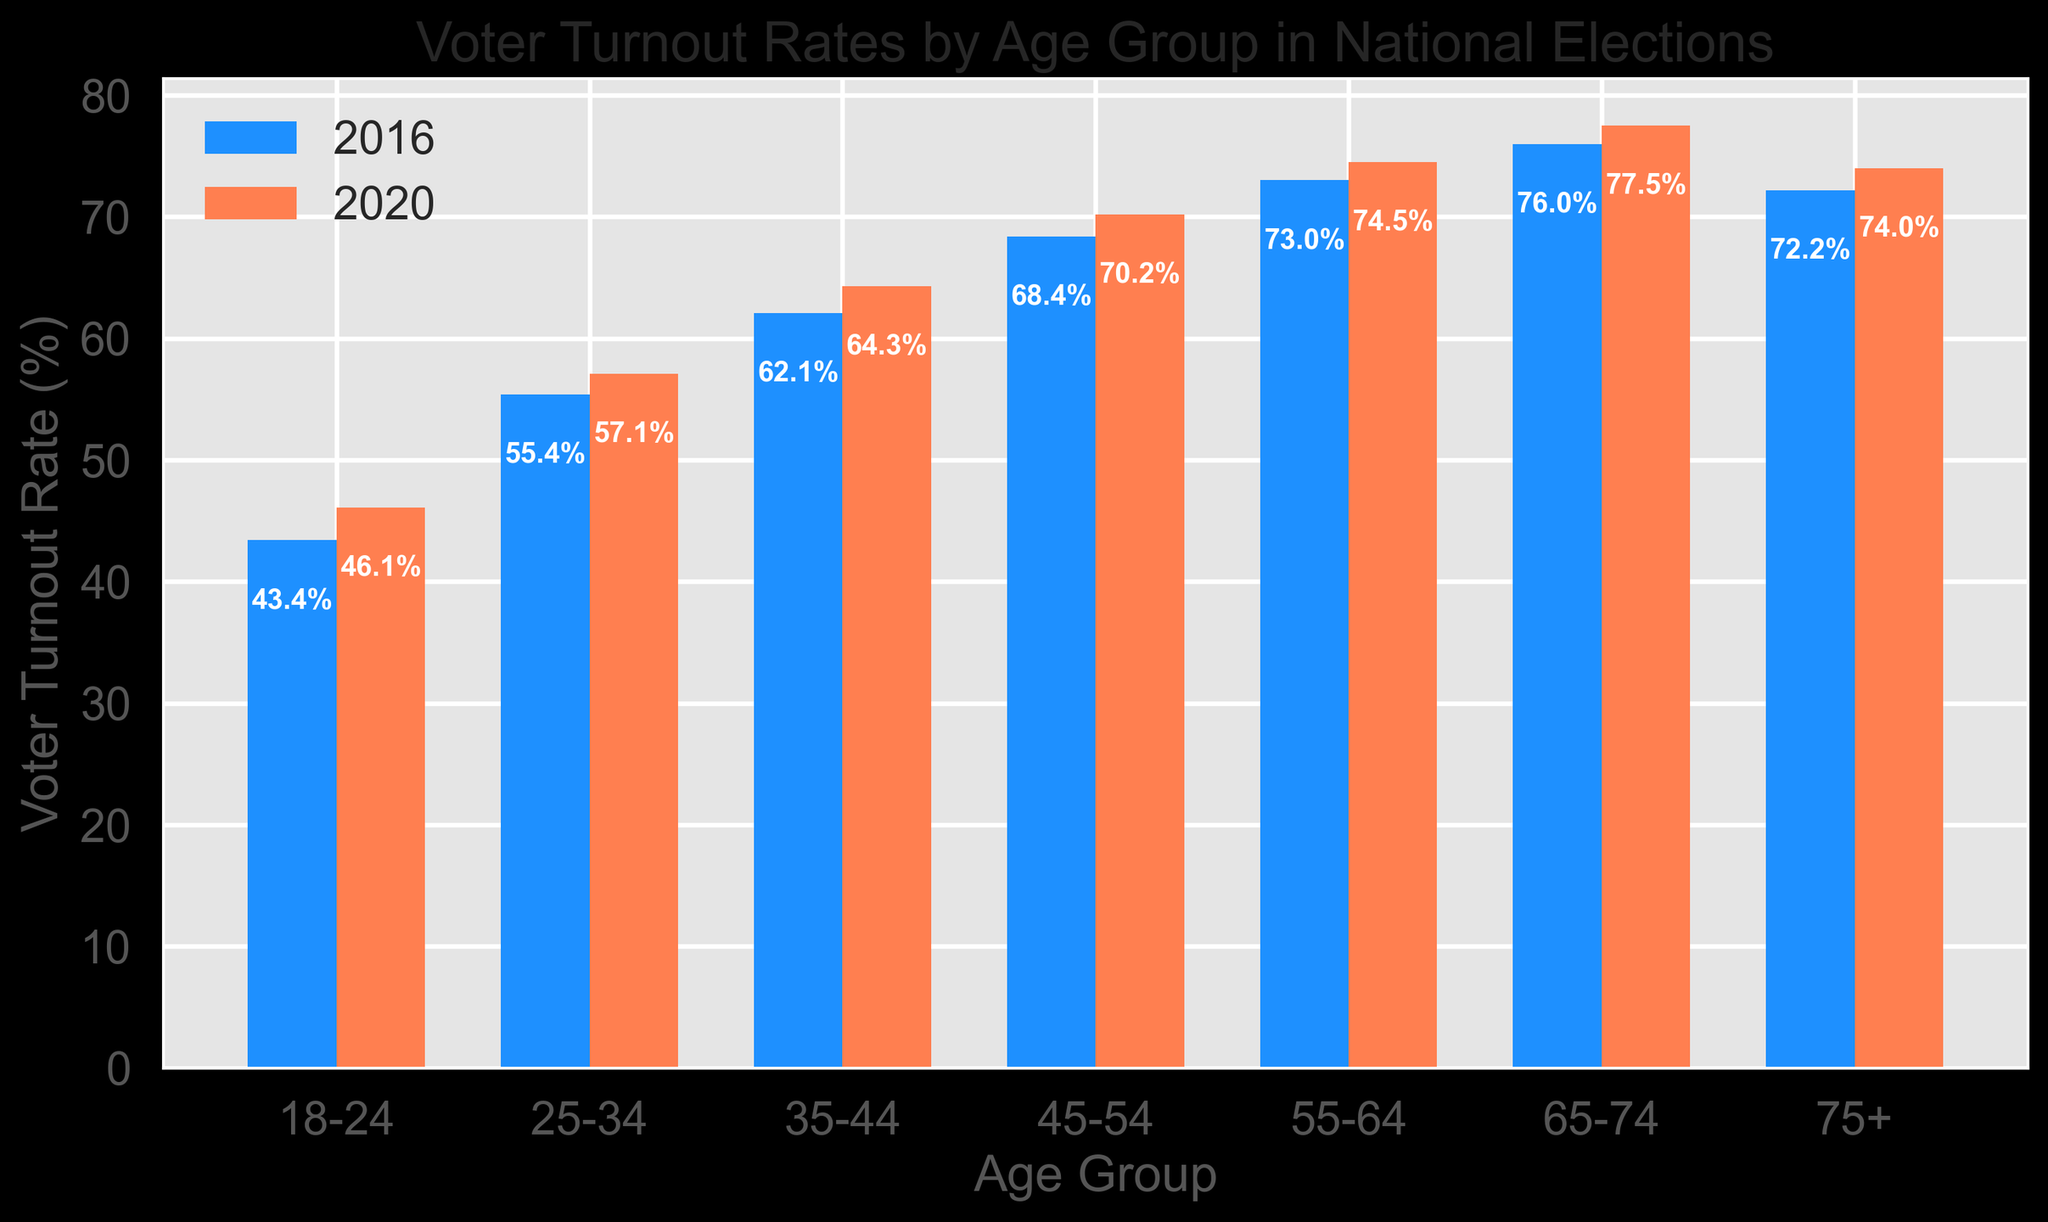What is the voter turnout rate for the 18-24 age group in 2020? Locate the bar corresponding to the 18-24 age group and read the height of the bar labeled for the year 2020.
Answer: 46.1% Which age group saw the highest voter turnout rate in 2016? Compare the heights of all bars labeled for the year 2016 and identify the tallest bar, which corresponds to the highest voter turnout rate.
Answer: 65-74 How much did the voter turnout rate for the 25-34 age group increase from 2016 to 2020? Subtract the 2016 voter turnout rate for the 25-34 age group from the 2020 voter turnout rate for the same group: 57.1 - 55.4.
Answer: 1.7% Which age group had a voter turnout rate below 50% in both 2016 and 2020? Check the bars in both 2016 and 2020 and identify any age group where both bars are below the 50% mark.
Answer: 18-24 What is the difference in voter turnout rate between the 65-74 and 75+ age groups in 2020? Subtract the 2020 voter turnout rate for the 75+ age group from the 2020 voter turnout rate for the 65-74 age group: 77.5 - 74.0.
Answer: 3.5% Which age group saw the least increase in voter turnout rate from 2016 to 2020? Calculate the difference between the voter turnout rates for 2016 and 2020 for each age group and identify the smallest difference.
Answer: 18-24 What is the average voter turnout rate for the 35-44 age group across both years? Add the voter turnout rates for 2016 and 2020 for the 35-44 age group and divide by 2: (62.1 + 64.3) / 2.
Answer: 63.2% How many age groups had a voter turnout rate exceeding 70% in 2020? Count the number of bars labeled for 2020 that surpass the 70% mark.
Answer: 3 (45-54, 55-64, 65-74) Which age group experienced the greatest increase in voter turnout rate from 2016 to 2020? Calculate the increase in voter turnout rate for each age group and identify the largest increase.
Answer: 35-44 Is the voter turnout rate for the 55-64 age group in 2020 higher or lower than that for the 75+ age group in 2020? Compare the heights of the bars for the 55-64 age group and the 75+ age group labeled for the year 2020.
Answer: Higher 